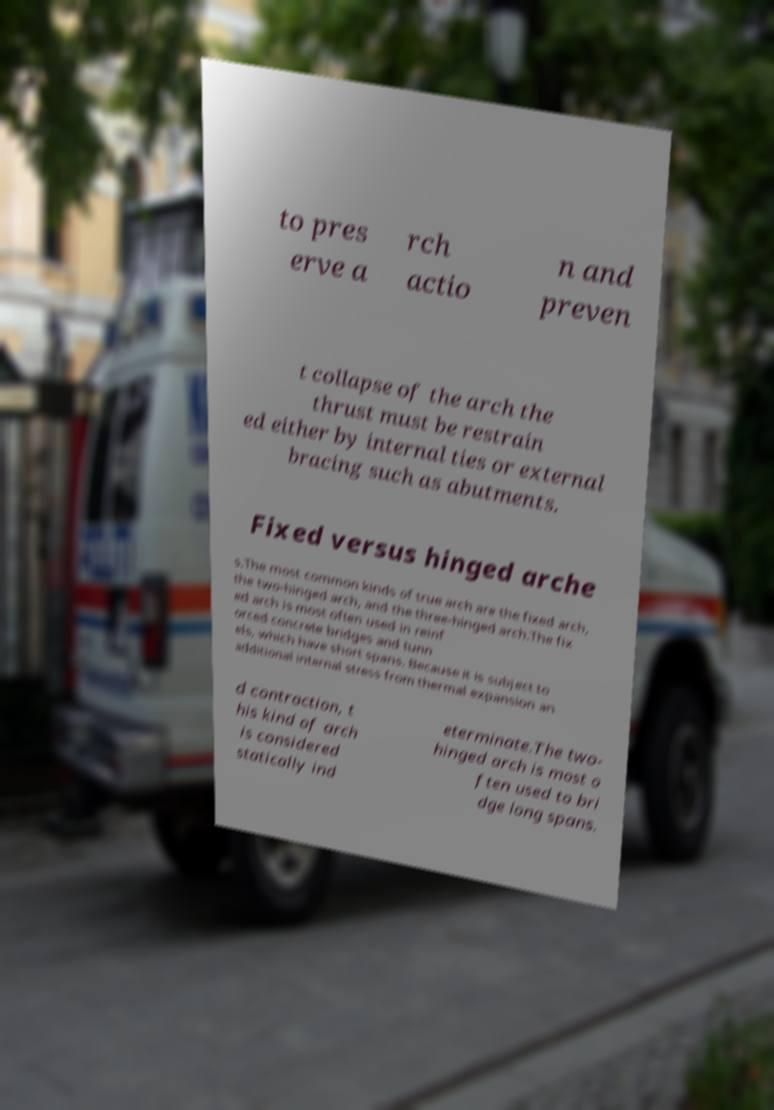Can you accurately transcribe the text from the provided image for me? to pres erve a rch actio n and preven t collapse of the arch the thrust must be restrain ed either by internal ties or external bracing such as abutments. Fixed versus hinged arche s.The most common kinds of true arch are the fixed arch, the two-hinged arch, and the three-hinged arch.The fix ed arch is most often used in reinf orced concrete bridges and tunn els, which have short spans. Because it is subject to additional internal stress from thermal expansion an d contraction, t his kind of arch is considered statically ind eterminate.The two- hinged arch is most o ften used to bri dge long spans. 